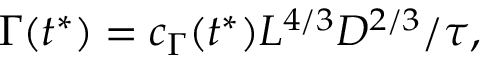<formula> <loc_0><loc_0><loc_500><loc_500>\Gamma ( t ^ { * } ) = c _ { \Gamma } ( t ^ { * } ) L ^ { 4 / 3 } D ^ { 2 / 3 } / \tau ,</formula> 